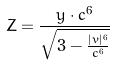Convert formula to latex. <formula><loc_0><loc_0><loc_500><loc_500>Z = \frac { y \cdot c ^ { 6 } } { \sqrt { 3 - \frac { | v | ^ { 6 } } { c ^ { 6 } } } }</formula> 